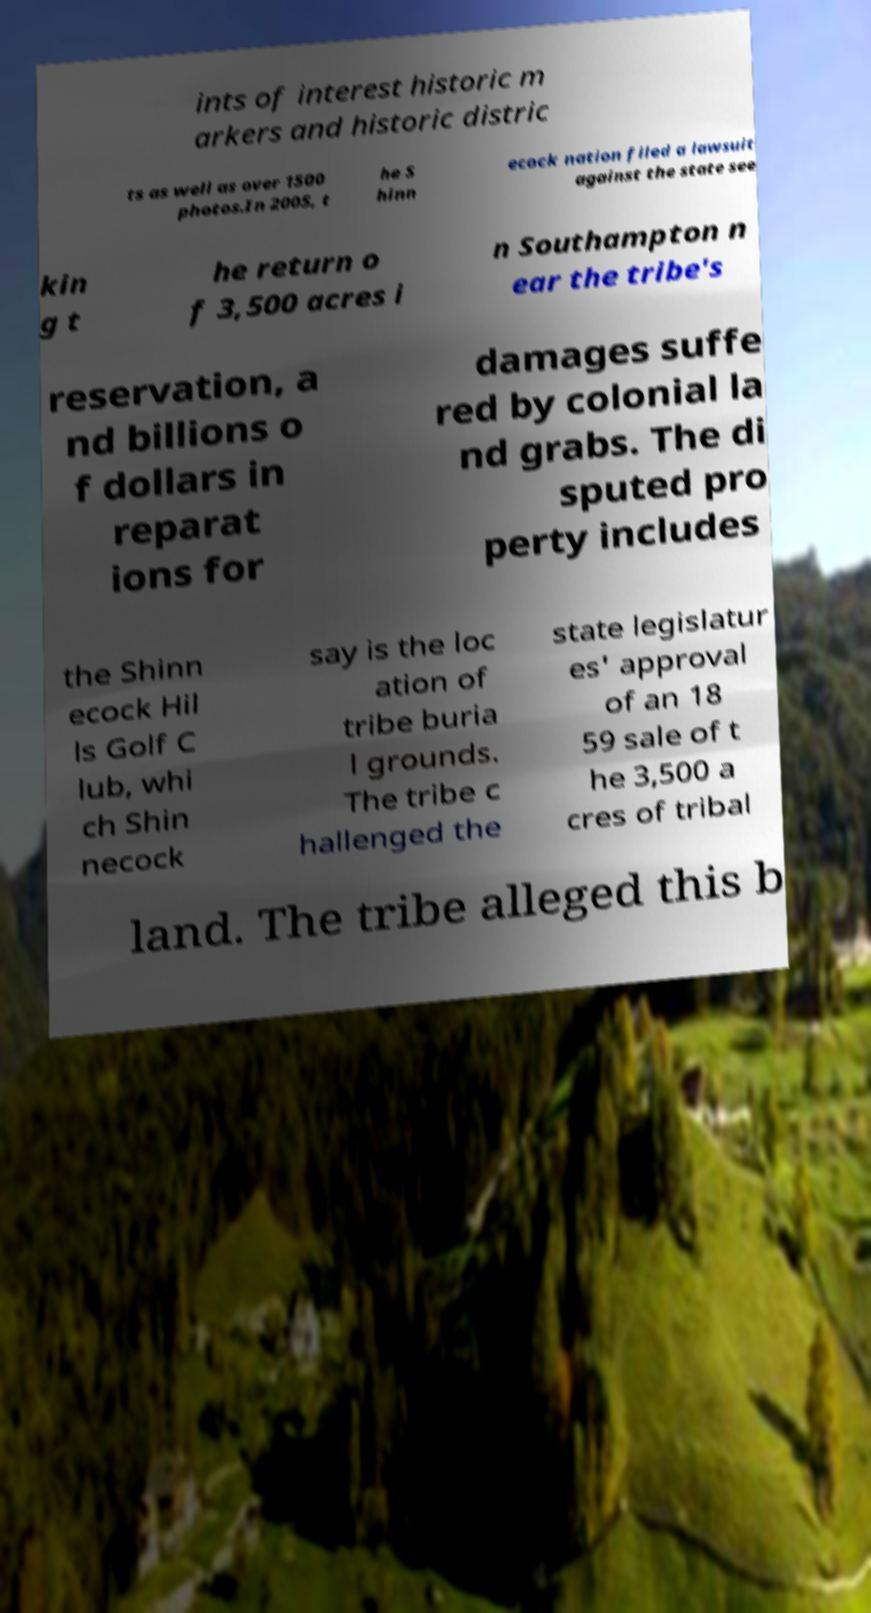Could you extract and type out the text from this image? ints of interest historic m arkers and historic distric ts as well as over 1500 photos.In 2005, t he S hinn ecock nation filed a lawsuit against the state see kin g t he return o f 3,500 acres i n Southampton n ear the tribe's reservation, a nd billions o f dollars in reparat ions for damages suffe red by colonial la nd grabs. The di sputed pro perty includes the Shinn ecock Hil ls Golf C lub, whi ch Shin necock say is the loc ation of tribe buria l grounds. The tribe c hallenged the state legislatur es' approval of an 18 59 sale of t he 3,500 a cres of tribal land. The tribe alleged this b 